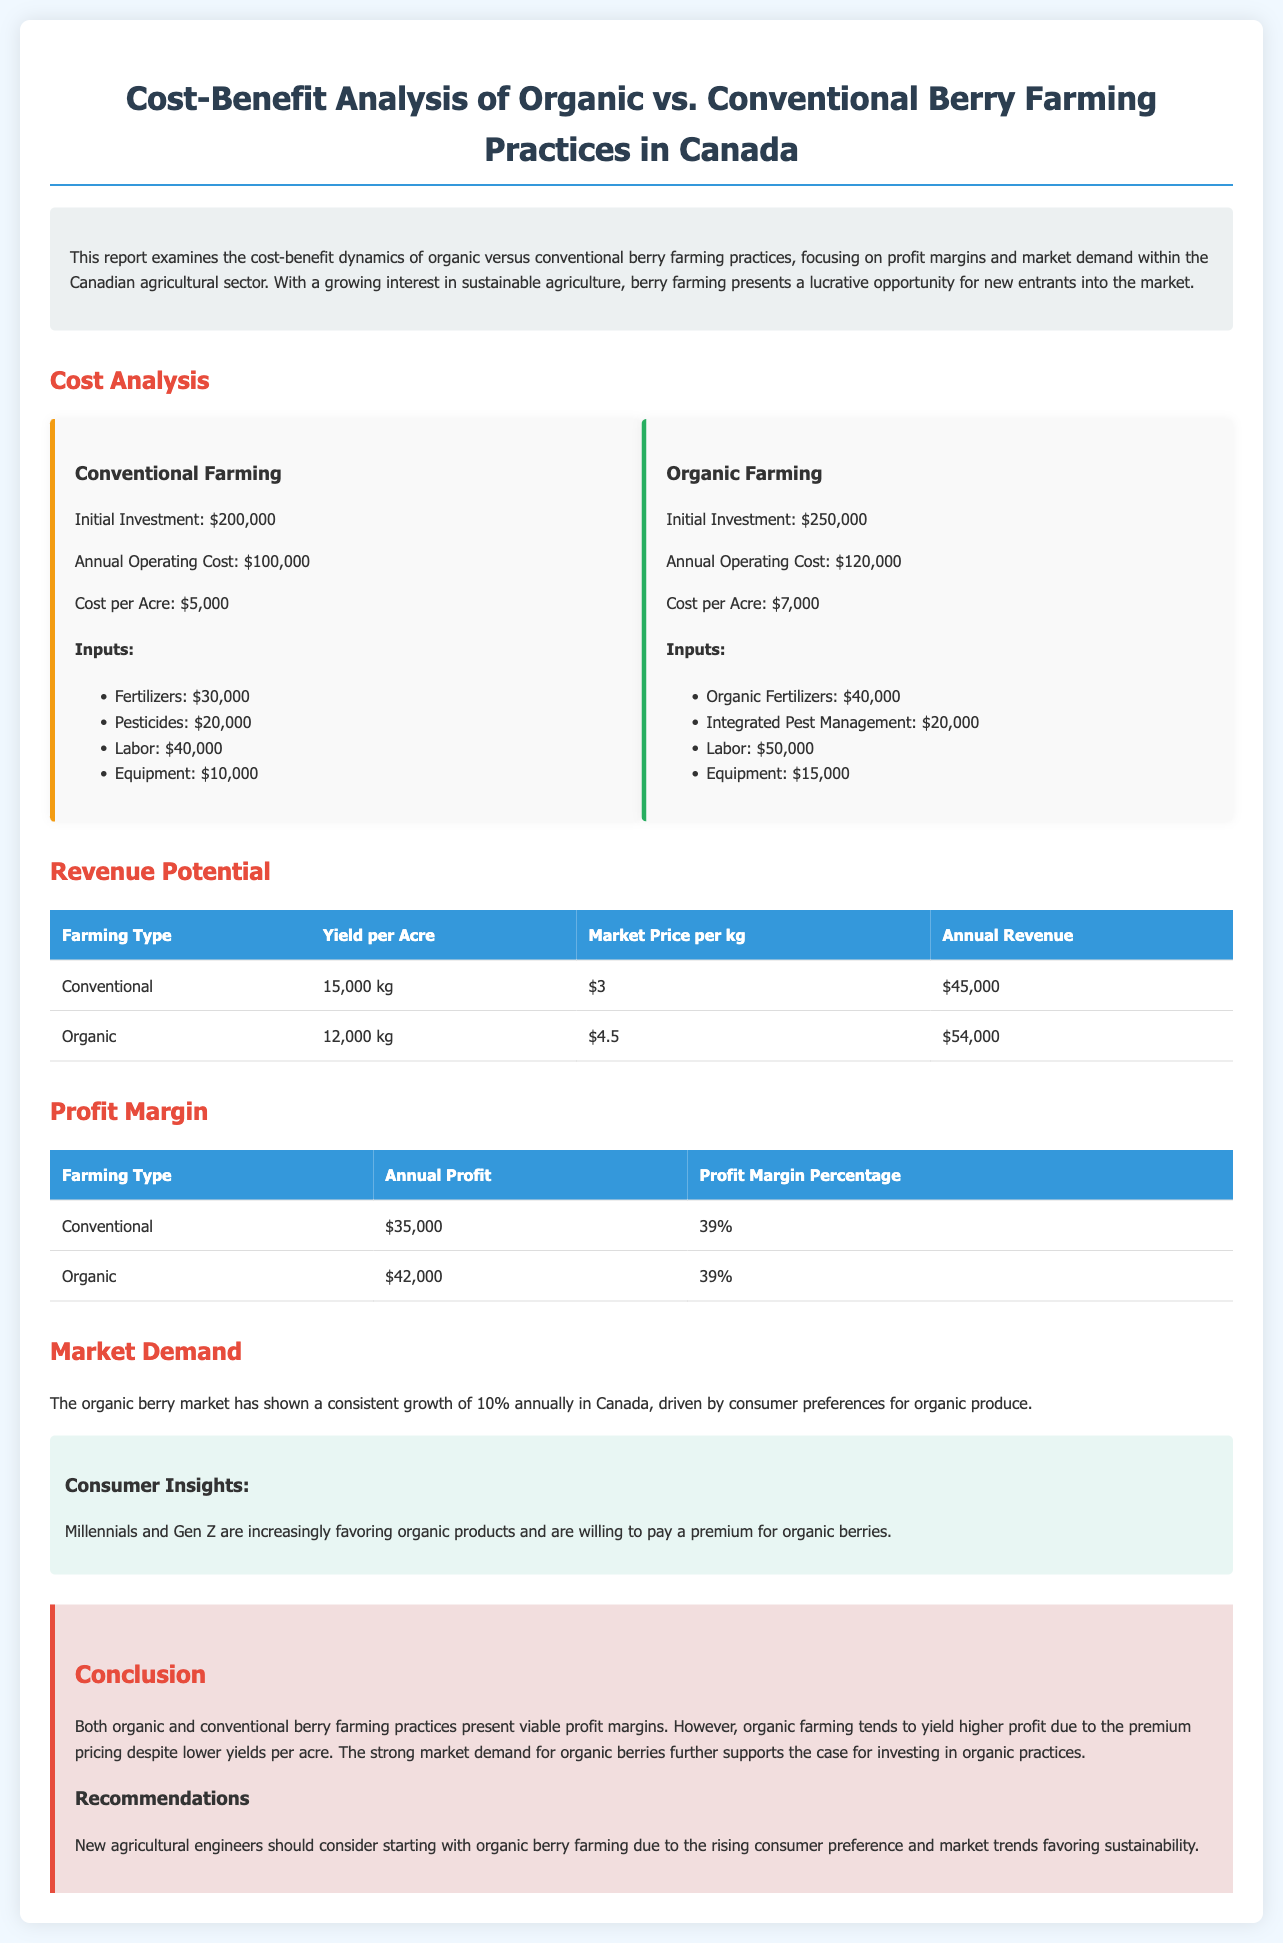What is the initial investment for conventional farming? The initial investment for conventional farming is stated in the cost analysis section of the report.
Answer: $200,000 What is the annual operating cost for organic farming? The annual operating cost for organic farming is found in the cost analysis section.
Answer: $120,000 What is the profit margin percentage for organic farming? The profit margin percentage for organic farming can be found in the profit margin table.
Answer: 39% What is the yield per acre for conventional farming? The yield per acre for conventional farming is detailed in the revenue potential table.
Answer: 15,000 kg What is the annual revenue for organic farming? The annual revenue for organic farming is calculated based on yield and market price, as shown in the revenue potential table.
Answer: $54,000 Which type of farming tends to yield higher profit? The conclusion summarizes which farming type yields higher profit based on profit margins and revenue.
Answer: Organic farming What is the market growth rate for organic berries in Canada? The market growth rate for organic berries is mentioned in the market demand section.
Answer: 10% What is the market price per kg for organic berries? The market price per kg for organic berries is listed in the revenue potential table.
Answer: $4.5 What is the estimated labor cost for conventional farming? The labor cost for conventional farming can be found in the cost analysis section.
Answer: $40,000 